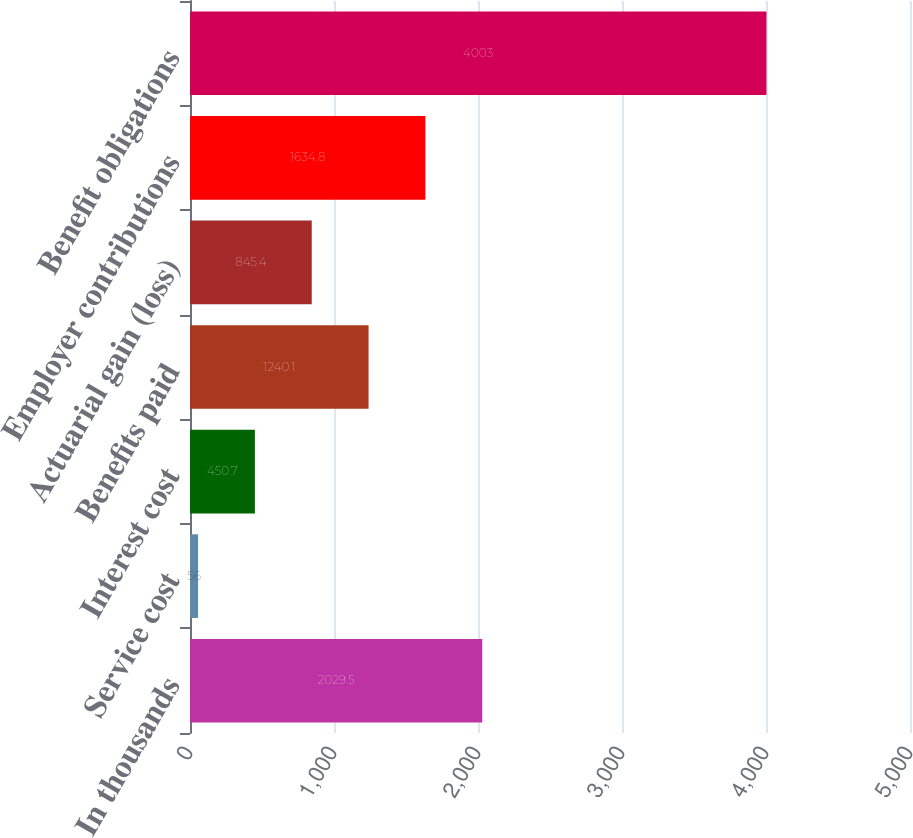Convert chart to OTSL. <chart><loc_0><loc_0><loc_500><loc_500><bar_chart><fcel>In thousands<fcel>Service cost<fcel>Interest cost<fcel>Benefits paid<fcel>Actuarial gain (loss)<fcel>Employer contributions<fcel>Benefit obligations<nl><fcel>2029.5<fcel>56<fcel>450.7<fcel>1240.1<fcel>845.4<fcel>1634.8<fcel>4003<nl></chart> 